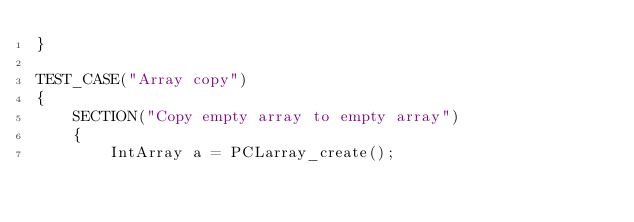Convert code to text. <code><loc_0><loc_0><loc_500><loc_500><_C++_>}

TEST_CASE("Array copy")
{
    SECTION("Copy empty array to empty array")
    {
        IntArray a = PCLarray_create();</code> 